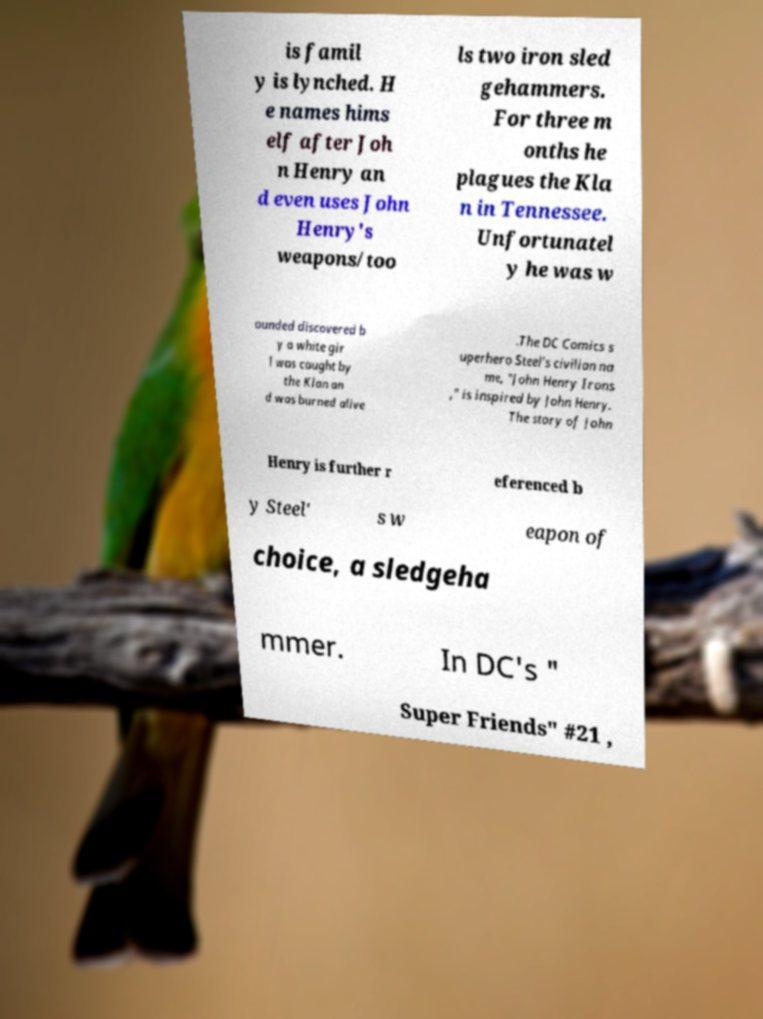For documentation purposes, I need the text within this image transcribed. Could you provide that? is famil y is lynched. H e names hims elf after Joh n Henry an d even uses John Henry's weapons/too ls two iron sled gehammers. For three m onths he plagues the Kla n in Tennessee. Unfortunatel y he was w ounded discovered b y a white gir l was caught by the Klan an d was burned alive .The DC Comics s uperhero Steel's civilian na me, "John Henry Irons ," is inspired by John Henry. The story of John Henry is further r eferenced b y Steel' s w eapon of choice, a sledgeha mmer. In DC's " Super Friends" #21 , 